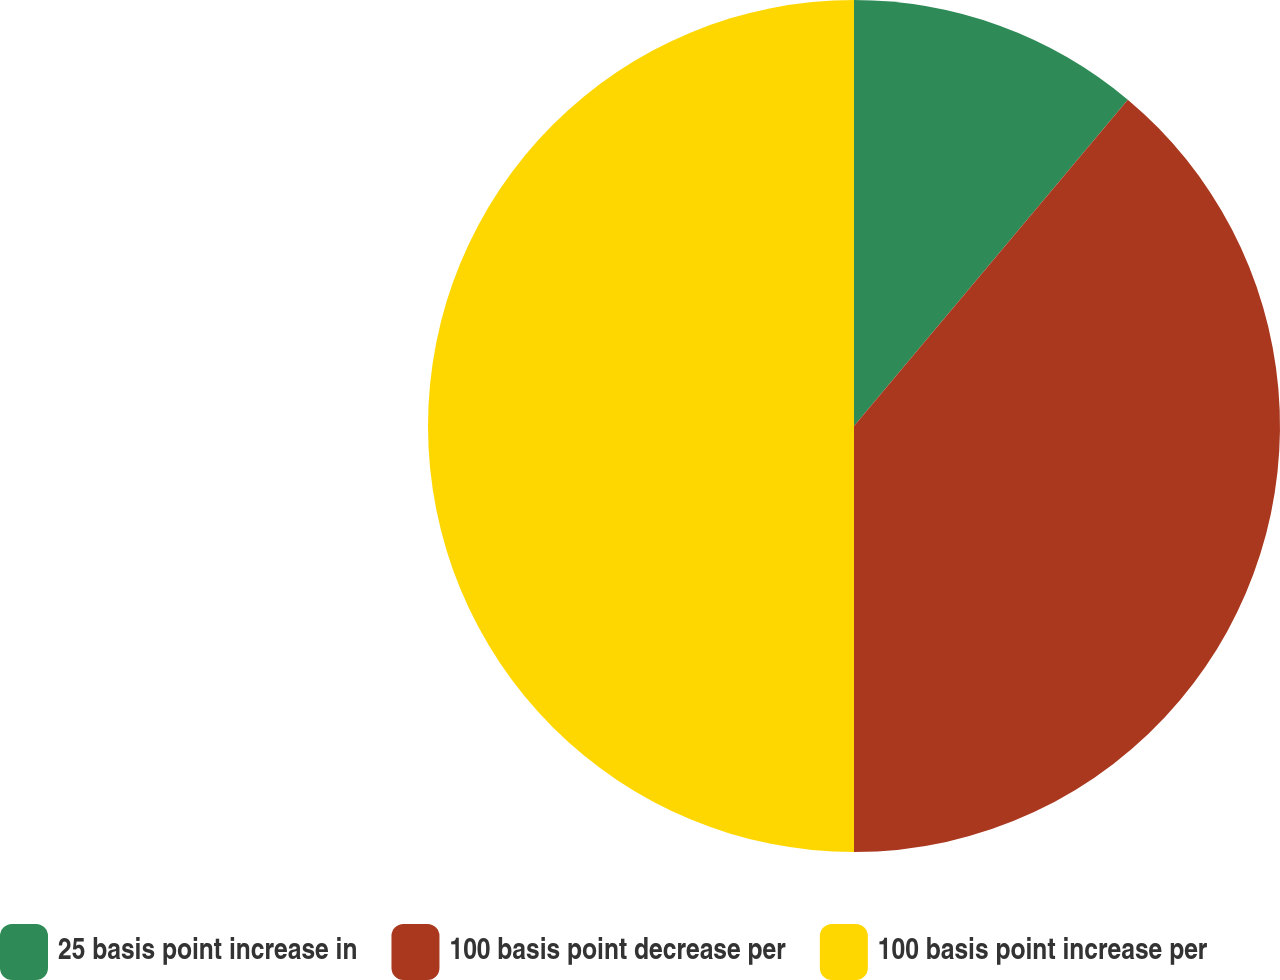Convert chart to OTSL. <chart><loc_0><loc_0><loc_500><loc_500><pie_chart><fcel>25 basis point increase in<fcel>100 basis point decrease per<fcel>100 basis point increase per<nl><fcel>11.11%<fcel>38.89%<fcel>50.0%<nl></chart> 